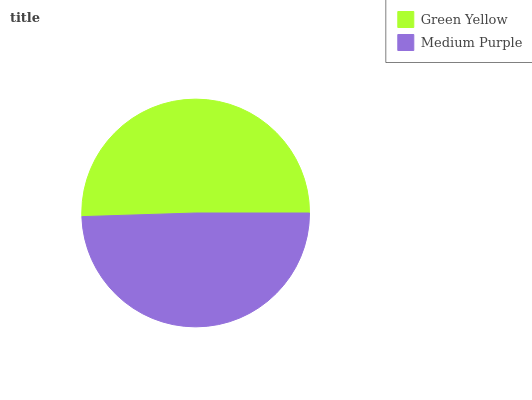Is Medium Purple the minimum?
Answer yes or no. Yes. Is Green Yellow the maximum?
Answer yes or no. Yes. Is Medium Purple the maximum?
Answer yes or no. No. Is Green Yellow greater than Medium Purple?
Answer yes or no. Yes. Is Medium Purple less than Green Yellow?
Answer yes or no. Yes. Is Medium Purple greater than Green Yellow?
Answer yes or no. No. Is Green Yellow less than Medium Purple?
Answer yes or no. No. Is Green Yellow the high median?
Answer yes or no. Yes. Is Medium Purple the low median?
Answer yes or no. Yes. Is Medium Purple the high median?
Answer yes or no. No. Is Green Yellow the low median?
Answer yes or no. No. 